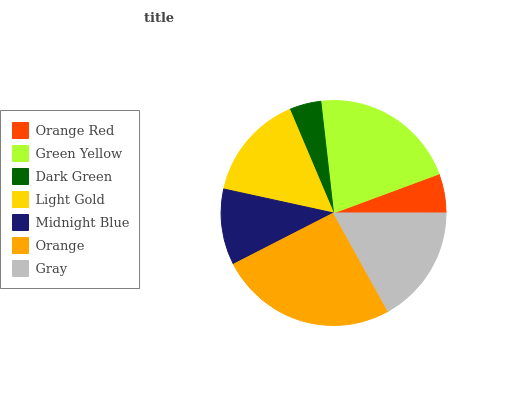Is Dark Green the minimum?
Answer yes or no. Yes. Is Orange the maximum?
Answer yes or no. Yes. Is Green Yellow the minimum?
Answer yes or no. No. Is Green Yellow the maximum?
Answer yes or no. No. Is Green Yellow greater than Orange Red?
Answer yes or no. Yes. Is Orange Red less than Green Yellow?
Answer yes or no. Yes. Is Orange Red greater than Green Yellow?
Answer yes or no. No. Is Green Yellow less than Orange Red?
Answer yes or no. No. Is Light Gold the high median?
Answer yes or no. Yes. Is Light Gold the low median?
Answer yes or no. Yes. Is Green Yellow the high median?
Answer yes or no. No. Is Orange Red the low median?
Answer yes or no. No. 